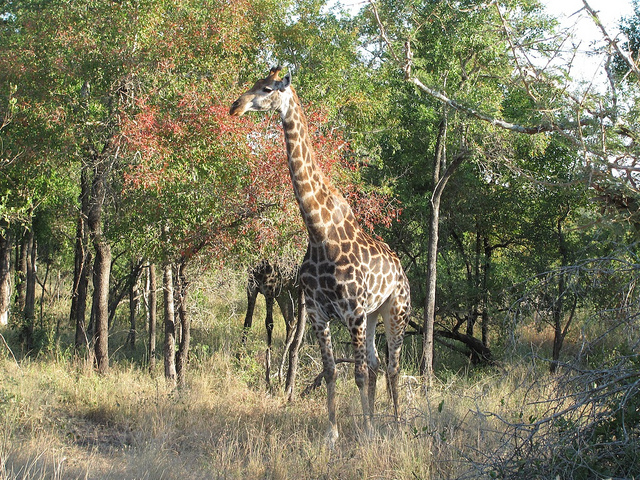What time of day does this photo appear to have been taken? Judging by the shadows and the quality of the light, it seems that this photo was taken in the late afternoon, when the sun is lower on the horizon and casts longer shadows. 